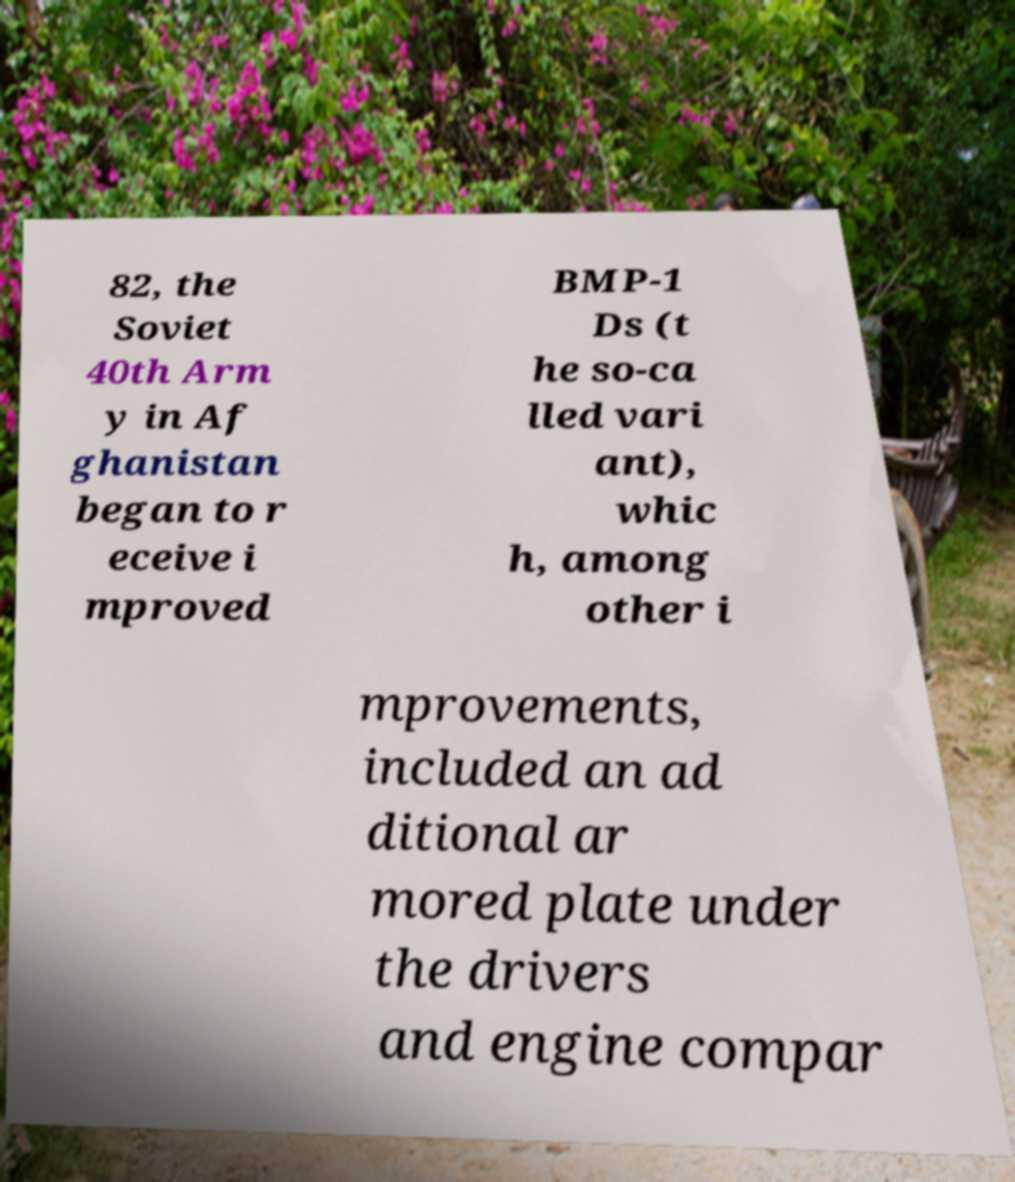Could you extract and type out the text from this image? 82, the Soviet 40th Arm y in Af ghanistan began to r eceive i mproved BMP-1 Ds (t he so-ca lled vari ant), whic h, among other i mprovements, included an ad ditional ar mored plate under the drivers and engine compar 